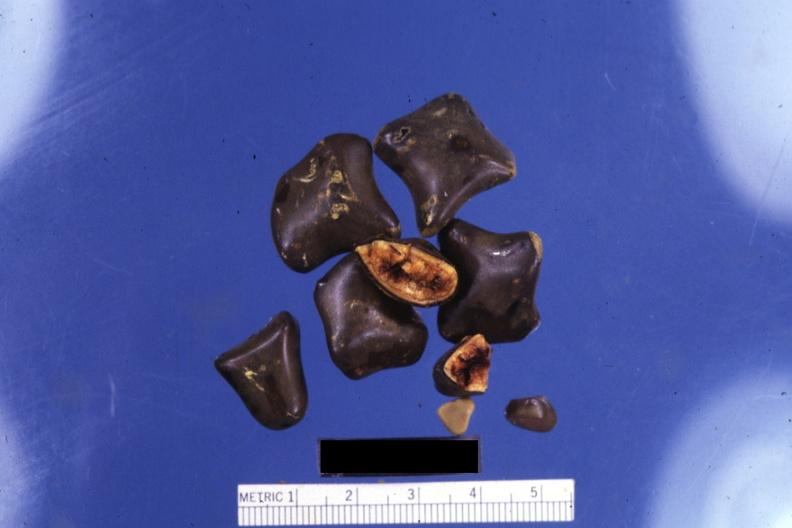s liver present?
Answer the question using a single word or phrase. Yes 